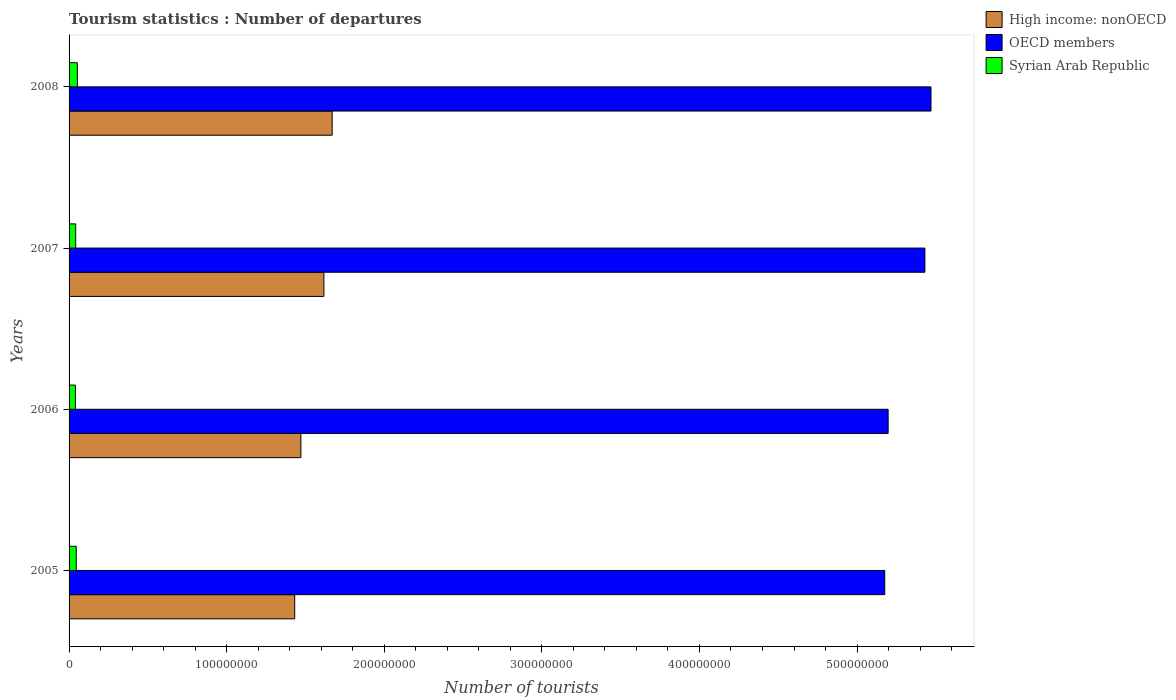Are the number of bars per tick equal to the number of legend labels?
Offer a terse response. Yes. Are the number of bars on each tick of the Y-axis equal?
Offer a very short reply. Yes. What is the number of tourist departures in High income: nonOECD in 2008?
Your response must be concise. 1.67e+08. Across all years, what is the maximum number of tourist departures in OECD members?
Make the answer very short. 5.47e+08. Across all years, what is the minimum number of tourist departures in OECD members?
Keep it short and to the point. 5.18e+08. What is the total number of tourist departures in High income: nonOECD in the graph?
Give a very brief answer. 6.19e+08. What is the difference between the number of tourist departures in Syrian Arab Republic in 2006 and that in 2008?
Provide a short and direct response. -1.21e+06. What is the difference between the number of tourist departures in Syrian Arab Republic in 2005 and the number of tourist departures in High income: nonOECD in 2008?
Provide a short and direct response. -1.62e+08. What is the average number of tourist departures in OECD members per year?
Offer a terse response. 5.32e+08. In the year 2006, what is the difference between the number of tourist departures in OECD members and number of tourist departures in High income: nonOECD?
Your answer should be compact. 3.73e+08. What is the ratio of the number of tourist departures in High income: nonOECD in 2007 to that in 2008?
Give a very brief answer. 0.97. Is the number of tourist departures in High income: nonOECD in 2006 less than that in 2007?
Provide a succinct answer. Yes. Is the difference between the number of tourist departures in OECD members in 2006 and 2007 greater than the difference between the number of tourist departures in High income: nonOECD in 2006 and 2007?
Your response must be concise. No. What is the difference between the highest and the second highest number of tourist departures in Syrian Arab Republic?
Keep it short and to the point. 6.89e+05. What is the difference between the highest and the lowest number of tourist departures in Syrian Arab Republic?
Ensure brevity in your answer.  1.21e+06. In how many years, is the number of tourist departures in OECD members greater than the average number of tourist departures in OECD members taken over all years?
Ensure brevity in your answer.  2. Is the sum of the number of tourist departures in Syrian Arab Republic in 2005 and 2007 greater than the maximum number of tourist departures in OECD members across all years?
Keep it short and to the point. No. What does the 1st bar from the top in 2008 represents?
Your answer should be compact. Syrian Arab Republic. What does the 1st bar from the bottom in 2008 represents?
Your answer should be compact. High income: nonOECD. How many bars are there?
Offer a terse response. 12. Are all the bars in the graph horizontal?
Provide a succinct answer. Yes. How many years are there in the graph?
Ensure brevity in your answer.  4. What is the difference between two consecutive major ticks on the X-axis?
Offer a terse response. 1.00e+08. Are the values on the major ticks of X-axis written in scientific E-notation?
Your answer should be compact. No. Does the graph contain grids?
Your response must be concise. No. Where does the legend appear in the graph?
Ensure brevity in your answer.  Top right. How are the legend labels stacked?
Keep it short and to the point. Vertical. What is the title of the graph?
Your answer should be very brief. Tourism statistics : Number of departures. What is the label or title of the X-axis?
Make the answer very short. Number of tourists. What is the label or title of the Y-axis?
Offer a terse response. Years. What is the Number of tourists of High income: nonOECD in 2005?
Keep it short and to the point. 1.43e+08. What is the Number of tourists of OECD members in 2005?
Offer a very short reply. 5.18e+08. What is the Number of tourists in Syrian Arab Republic in 2005?
Keep it short and to the point. 4.56e+06. What is the Number of tourists of High income: nonOECD in 2006?
Provide a succinct answer. 1.47e+08. What is the Number of tourists in OECD members in 2006?
Your answer should be compact. 5.20e+08. What is the Number of tourists of Syrian Arab Republic in 2006?
Keep it short and to the point. 4.04e+06. What is the Number of tourists in High income: nonOECD in 2007?
Ensure brevity in your answer.  1.62e+08. What is the Number of tourists of OECD members in 2007?
Offer a very short reply. 5.43e+08. What is the Number of tourists in Syrian Arab Republic in 2007?
Your answer should be very brief. 4.20e+06. What is the Number of tourists in High income: nonOECD in 2008?
Ensure brevity in your answer.  1.67e+08. What is the Number of tourists in OECD members in 2008?
Make the answer very short. 5.47e+08. What is the Number of tourists of Syrian Arab Republic in 2008?
Offer a very short reply. 5.25e+06. Across all years, what is the maximum Number of tourists of High income: nonOECD?
Your answer should be compact. 1.67e+08. Across all years, what is the maximum Number of tourists of OECD members?
Make the answer very short. 5.47e+08. Across all years, what is the maximum Number of tourists of Syrian Arab Republic?
Your answer should be very brief. 5.25e+06. Across all years, what is the minimum Number of tourists in High income: nonOECD?
Make the answer very short. 1.43e+08. Across all years, what is the minimum Number of tourists of OECD members?
Your answer should be very brief. 5.18e+08. Across all years, what is the minimum Number of tourists of Syrian Arab Republic?
Your answer should be very brief. 4.04e+06. What is the total Number of tourists of High income: nonOECD in the graph?
Provide a succinct answer. 6.19e+08. What is the total Number of tourists of OECD members in the graph?
Keep it short and to the point. 2.13e+09. What is the total Number of tourists of Syrian Arab Republic in the graph?
Make the answer very short. 1.81e+07. What is the difference between the Number of tourists in High income: nonOECD in 2005 and that in 2006?
Provide a succinct answer. -3.92e+06. What is the difference between the Number of tourists in OECD members in 2005 and that in 2006?
Offer a terse response. -2.15e+06. What is the difference between the Number of tourists in Syrian Arab Republic in 2005 and that in 2006?
Ensure brevity in your answer.  5.22e+05. What is the difference between the Number of tourists of High income: nonOECD in 2005 and that in 2007?
Provide a short and direct response. -1.85e+07. What is the difference between the Number of tourists of OECD members in 2005 and that in 2007?
Offer a terse response. -2.55e+07. What is the difference between the Number of tourists of Syrian Arab Republic in 2005 and that in 2007?
Ensure brevity in your answer.  3.68e+05. What is the difference between the Number of tourists of High income: nonOECD in 2005 and that in 2008?
Give a very brief answer. -2.38e+07. What is the difference between the Number of tourists in OECD members in 2005 and that in 2008?
Make the answer very short. -2.93e+07. What is the difference between the Number of tourists in Syrian Arab Republic in 2005 and that in 2008?
Offer a terse response. -6.89e+05. What is the difference between the Number of tourists of High income: nonOECD in 2006 and that in 2007?
Your answer should be very brief. -1.46e+07. What is the difference between the Number of tourists in OECD members in 2006 and that in 2007?
Offer a terse response. -2.33e+07. What is the difference between the Number of tourists in Syrian Arab Republic in 2006 and that in 2007?
Offer a very short reply. -1.54e+05. What is the difference between the Number of tourists in High income: nonOECD in 2006 and that in 2008?
Offer a terse response. -1.99e+07. What is the difference between the Number of tourists of OECD members in 2006 and that in 2008?
Give a very brief answer. -2.72e+07. What is the difference between the Number of tourists of Syrian Arab Republic in 2006 and that in 2008?
Your answer should be compact. -1.21e+06. What is the difference between the Number of tourists in High income: nonOECD in 2007 and that in 2008?
Your answer should be very brief. -5.25e+06. What is the difference between the Number of tourists of OECD members in 2007 and that in 2008?
Provide a succinct answer. -3.86e+06. What is the difference between the Number of tourists of Syrian Arab Republic in 2007 and that in 2008?
Your answer should be compact. -1.06e+06. What is the difference between the Number of tourists of High income: nonOECD in 2005 and the Number of tourists of OECD members in 2006?
Your answer should be very brief. -3.77e+08. What is the difference between the Number of tourists in High income: nonOECD in 2005 and the Number of tourists in Syrian Arab Republic in 2006?
Your answer should be very brief. 1.39e+08. What is the difference between the Number of tourists in OECD members in 2005 and the Number of tourists in Syrian Arab Republic in 2006?
Provide a succinct answer. 5.14e+08. What is the difference between the Number of tourists in High income: nonOECD in 2005 and the Number of tourists in OECD members in 2007?
Give a very brief answer. -4.00e+08. What is the difference between the Number of tourists of High income: nonOECD in 2005 and the Number of tourists of Syrian Arab Republic in 2007?
Make the answer very short. 1.39e+08. What is the difference between the Number of tourists in OECD members in 2005 and the Number of tourists in Syrian Arab Republic in 2007?
Keep it short and to the point. 5.13e+08. What is the difference between the Number of tourists of High income: nonOECD in 2005 and the Number of tourists of OECD members in 2008?
Your answer should be compact. -4.04e+08. What is the difference between the Number of tourists of High income: nonOECD in 2005 and the Number of tourists of Syrian Arab Republic in 2008?
Offer a very short reply. 1.38e+08. What is the difference between the Number of tourists in OECD members in 2005 and the Number of tourists in Syrian Arab Republic in 2008?
Keep it short and to the point. 5.12e+08. What is the difference between the Number of tourists of High income: nonOECD in 2006 and the Number of tourists of OECD members in 2007?
Ensure brevity in your answer.  -3.96e+08. What is the difference between the Number of tourists of High income: nonOECD in 2006 and the Number of tourists of Syrian Arab Republic in 2007?
Provide a short and direct response. 1.43e+08. What is the difference between the Number of tourists in OECD members in 2006 and the Number of tourists in Syrian Arab Republic in 2007?
Offer a terse response. 5.16e+08. What is the difference between the Number of tourists of High income: nonOECD in 2006 and the Number of tourists of OECD members in 2008?
Your response must be concise. -4.00e+08. What is the difference between the Number of tourists of High income: nonOECD in 2006 and the Number of tourists of Syrian Arab Republic in 2008?
Give a very brief answer. 1.42e+08. What is the difference between the Number of tourists in OECD members in 2006 and the Number of tourists in Syrian Arab Republic in 2008?
Keep it short and to the point. 5.14e+08. What is the difference between the Number of tourists in High income: nonOECD in 2007 and the Number of tourists in OECD members in 2008?
Provide a succinct answer. -3.85e+08. What is the difference between the Number of tourists of High income: nonOECD in 2007 and the Number of tourists of Syrian Arab Republic in 2008?
Keep it short and to the point. 1.56e+08. What is the difference between the Number of tourists in OECD members in 2007 and the Number of tourists in Syrian Arab Republic in 2008?
Offer a terse response. 5.38e+08. What is the average Number of tourists of High income: nonOECD per year?
Provide a short and direct response. 1.55e+08. What is the average Number of tourists in OECD members per year?
Keep it short and to the point. 5.32e+08. What is the average Number of tourists in Syrian Arab Republic per year?
Offer a very short reply. 4.51e+06. In the year 2005, what is the difference between the Number of tourists of High income: nonOECD and Number of tourists of OECD members?
Provide a succinct answer. -3.74e+08. In the year 2005, what is the difference between the Number of tourists in High income: nonOECD and Number of tourists in Syrian Arab Republic?
Ensure brevity in your answer.  1.39e+08. In the year 2005, what is the difference between the Number of tourists of OECD members and Number of tourists of Syrian Arab Republic?
Your answer should be compact. 5.13e+08. In the year 2006, what is the difference between the Number of tourists of High income: nonOECD and Number of tourists of OECD members?
Your answer should be compact. -3.73e+08. In the year 2006, what is the difference between the Number of tourists in High income: nonOECD and Number of tourists in Syrian Arab Republic?
Give a very brief answer. 1.43e+08. In the year 2006, what is the difference between the Number of tourists of OECD members and Number of tourists of Syrian Arab Republic?
Your response must be concise. 5.16e+08. In the year 2007, what is the difference between the Number of tourists of High income: nonOECD and Number of tourists of OECD members?
Keep it short and to the point. -3.81e+08. In the year 2007, what is the difference between the Number of tourists in High income: nonOECD and Number of tourists in Syrian Arab Republic?
Provide a succinct answer. 1.58e+08. In the year 2007, what is the difference between the Number of tourists in OECD members and Number of tourists in Syrian Arab Republic?
Give a very brief answer. 5.39e+08. In the year 2008, what is the difference between the Number of tourists of High income: nonOECD and Number of tourists of OECD members?
Offer a terse response. -3.80e+08. In the year 2008, what is the difference between the Number of tourists in High income: nonOECD and Number of tourists in Syrian Arab Republic?
Keep it short and to the point. 1.62e+08. In the year 2008, what is the difference between the Number of tourists of OECD members and Number of tourists of Syrian Arab Republic?
Provide a short and direct response. 5.42e+08. What is the ratio of the Number of tourists of High income: nonOECD in 2005 to that in 2006?
Offer a terse response. 0.97. What is the ratio of the Number of tourists of Syrian Arab Republic in 2005 to that in 2006?
Keep it short and to the point. 1.13. What is the ratio of the Number of tourists in High income: nonOECD in 2005 to that in 2007?
Provide a succinct answer. 0.89. What is the ratio of the Number of tourists of OECD members in 2005 to that in 2007?
Ensure brevity in your answer.  0.95. What is the ratio of the Number of tourists in Syrian Arab Republic in 2005 to that in 2007?
Ensure brevity in your answer.  1.09. What is the ratio of the Number of tourists of High income: nonOECD in 2005 to that in 2008?
Offer a very short reply. 0.86. What is the ratio of the Number of tourists of OECD members in 2005 to that in 2008?
Your answer should be very brief. 0.95. What is the ratio of the Number of tourists in Syrian Arab Republic in 2005 to that in 2008?
Make the answer very short. 0.87. What is the ratio of the Number of tourists of High income: nonOECD in 2006 to that in 2007?
Keep it short and to the point. 0.91. What is the ratio of the Number of tourists in OECD members in 2006 to that in 2007?
Your response must be concise. 0.96. What is the ratio of the Number of tourists of Syrian Arab Republic in 2006 to that in 2007?
Offer a very short reply. 0.96. What is the ratio of the Number of tourists in High income: nonOECD in 2006 to that in 2008?
Offer a very short reply. 0.88. What is the ratio of the Number of tourists in OECD members in 2006 to that in 2008?
Provide a short and direct response. 0.95. What is the ratio of the Number of tourists in Syrian Arab Republic in 2006 to that in 2008?
Your answer should be very brief. 0.77. What is the ratio of the Number of tourists of High income: nonOECD in 2007 to that in 2008?
Offer a very short reply. 0.97. What is the ratio of the Number of tourists of Syrian Arab Republic in 2007 to that in 2008?
Your response must be concise. 0.8. What is the difference between the highest and the second highest Number of tourists of High income: nonOECD?
Offer a very short reply. 5.25e+06. What is the difference between the highest and the second highest Number of tourists in OECD members?
Provide a short and direct response. 3.86e+06. What is the difference between the highest and the second highest Number of tourists in Syrian Arab Republic?
Give a very brief answer. 6.89e+05. What is the difference between the highest and the lowest Number of tourists of High income: nonOECD?
Give a very brief answer. 2.38e+07. What is the difference between the highest and the lowest Number of tourists of OECD members?
Provide a succinct answer. 2.93e+07. What is the difference between the highest and the lowest Number of tourists of Syrian Arab Republic?
Your response must be concise. 1.21e+06. 